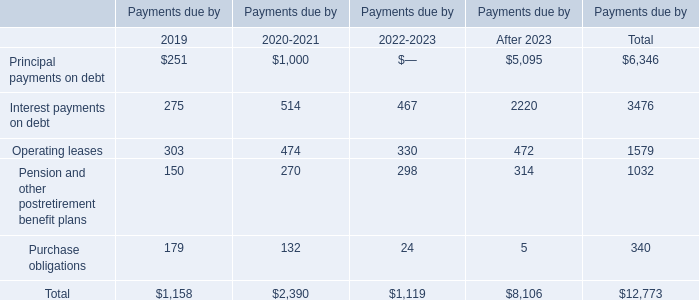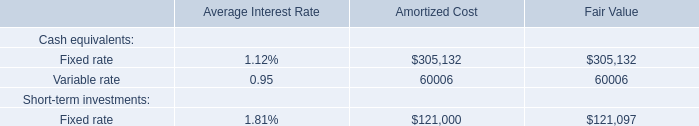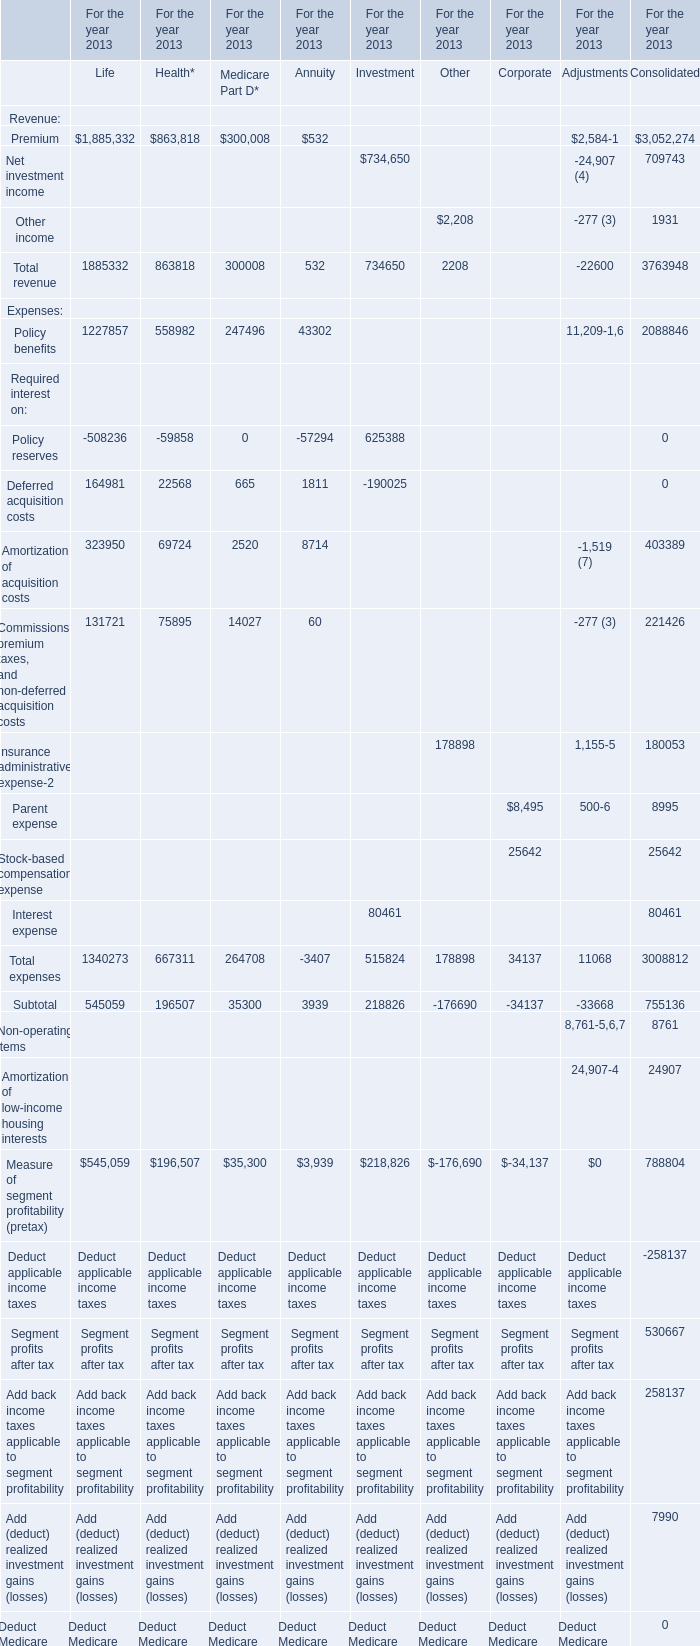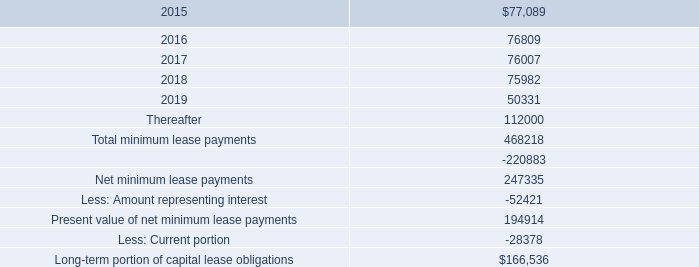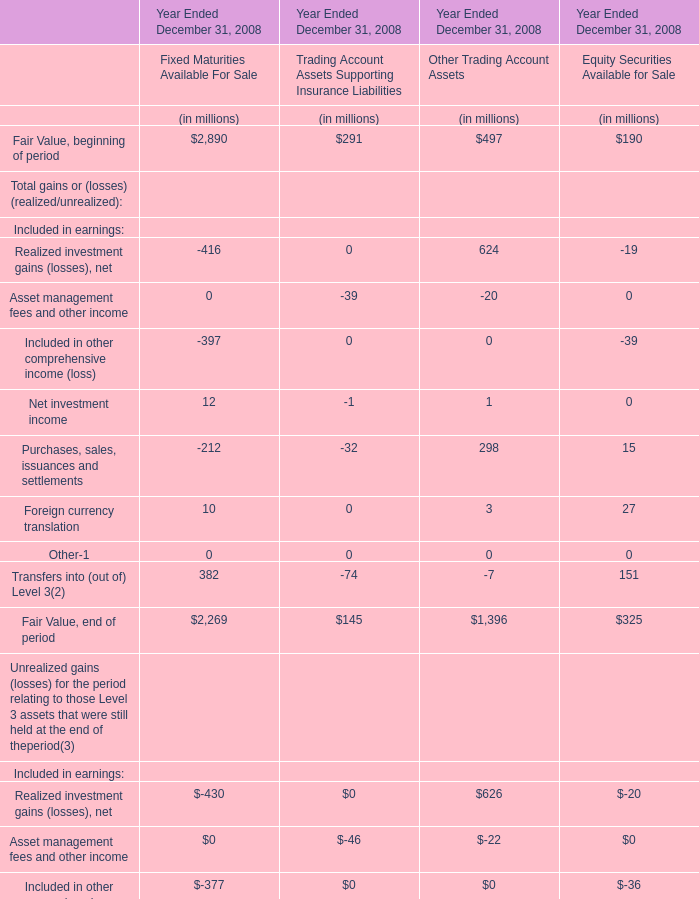What's the sum of Premium of For the year 2013 Consolidated, and Interest payments on debt of Payments due by After 2023 ? 
Computations: (3052274.0 + 2220.0)
Answer: 3054494.0. 